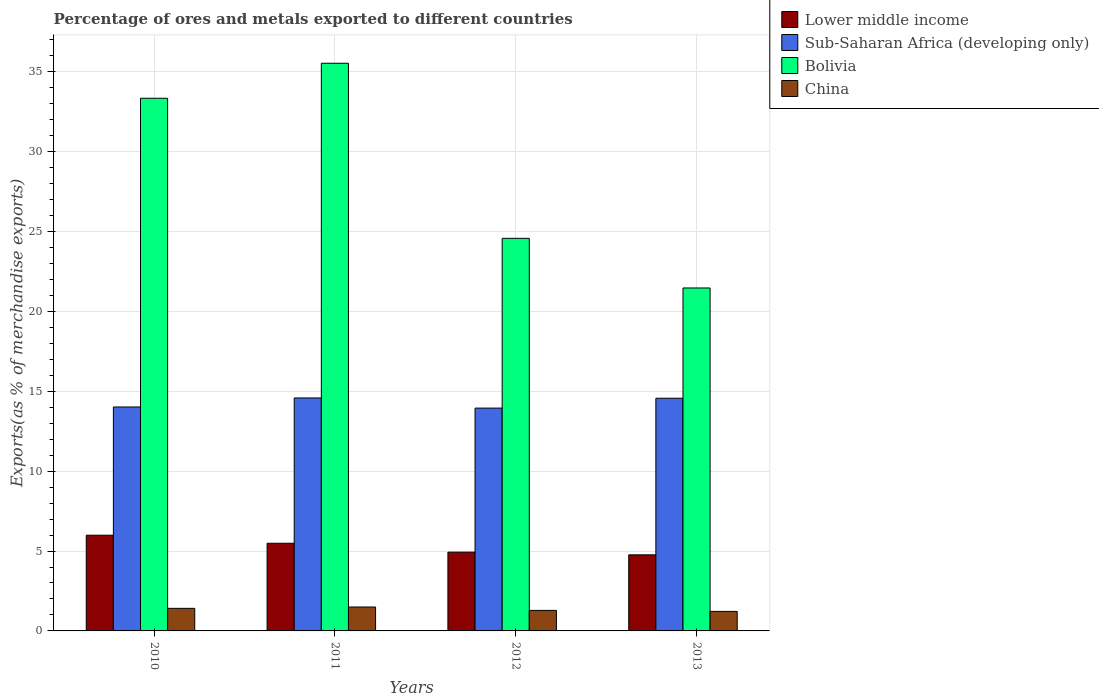How many groups of bars are there?
Keep it short and to the point. 4. Are the number of bars per tick equal to the number of legend labels?
Make the answer very short. Yes. Are the number of bars on each tick of the X-axis equal?
Your response must be concise. Yes. What is the label of the 4th group of bars from the left?
Offer a terse response. 2013. In how many cases, is the number of bars for a given year not equal to the number of legend labels?
Provide a short and direct response. 0. What is the percentage of exports to different countries in Sub-Saharan Africa (developing only) in 2011?
Make the answer very short. 14.58. Across all years, what is the maximum percentage of exports to different countries in Sub-Saharan Africa (developing only)?
Offer a very short reply. 14.58. Across all years, what is the minimum percentage of exports to different countries in Bolivia?
Your answer should be very brief. 21.46. In which year was the percentage of exports to different countries in Sub-Saharan Africa (developing only) maximum?
Your answer should be compact. 2011. In which year was the percentage of exports to different countries in China minimum?
Ensure brevity in your answer.  2013. What is the total percentage of exports to different countries in Sub-Saharan Africa (developing only) in the graph?
Provide a short and direct response. 57.11. What is the difference between the percentage of exports to different countries in Sub-Saharan Africa (developing only) in 2010 and that in 2012?
Keep it short and to the point. 0.07. What is the difference between the percentage of exports to different countries in Bolivia in 2011 and the percentage of exports to different countries in Lower middle income in 2013?
Provide a short and direct response. 30.77. What is the average percentage of exports to different countries in Lower middle income per year?
Your response must be concise. 5.29. In the year 2012, what is the difference between the percentage of exports to different countries in Sub-Saharan Africa (developing only) and percentage of exports to different countries in Lower middle income?
Offer a terse response. 9.02. What is the ratio of the percentage of exports to different countries in China in 2010 to that in 2011?
Provide a succinct answer. 0.94. Is the percentage of exports to different countries in Bolivia in 2012 less than that in 2013?
Make the answer very short. No. What is the difference between the highest and the second highest percentage of exports to different countries in China?
Your answer should be very brief. 0.08. What is the difference between the highest and the lowest percentage of exports to different countries in Sub-Saharan Africa (developing only)?
Your answer should be compact. 0.63. Is it the case that in every year, the sum of the percentage of exports to different countries in Lower middle income and percentage of exports to different countries in Sub-Saharan Africa (developing only) is greater than the sum of percentage of exports to different countries in China and percentage of exports to different countries in Bolivia?
Offer a very short reply. Yes. What does the 4th bar from the left in 2011 represents?
Provide a succinct answer. China. What does the 2nd bar from the right in 2012 represents?
Ensure brevity in your answer.  Bolivia. Is it the case that in every year, the sum of the percentage of exports to different countries in Bolivia and percentage of exports to different countries in Lower middle income is greater than the percentage of exports to different countries in China?
Give a very brief answer. Yes. Are all the bars in the graph horizontal?
Give a very brief answer. No. Are the values on the major ticks of Y-axis written in scientific E-notation?
Give a very brief answer. No. Does the graph contain any zero values?
Offer a very short reply. No. Where does the legend appear in the graph?
Ensure brevity in your answer.  Top right. How many legend labels are there?
Make the answer very short. 4. What is the title of the graph?
Offer a terse response. Percentage of ores and metals exported to different countries. What is the label or title of the X-axis?
Your answer should be very brief. Years. What is the label or title of the Y-axis?
Provide a succinct answer. Exports(as % of merchandise exports). What is the Exports(as % of merchandise exports) in Lower middle income in 2010?
Give a very brief answer. 5.99. What is the Exports(as % of merchandise exports) of Sub-Saharan Africa (developing only) in 2010?
Offer a terse response. 14.02. What is the Exports(as % of merchandise exports) of Bolivia in 2010?
Offer a terse response. 33.34. What is the Exports(as % of merchandise exports) of China in 2010?
Provide a succinct answer. 1.41. What is the Exports(as % of merchandise exports) of Lower middle income in 2011?
Keep it short and to the point. 5.49. What is the Exports(as % of merchandise exports) in Sub-Saharan Africa (developing only) in 2011?
Your response must be concise. 14.58. What is the Exports(as % of merchandise exports) in Bolivia in 2011?
Offer a very short reply. 35.53. What is the Exports(as % of merchandise exports) of China in 2011?
Provide a succinct answer. 1.5. What is the Exports(as % of merchandise exports) in Lower middle income in 2012?
Provide a short and direct response. 4.93. What is the Exports(as % of merchandise exports) in Sub-Saharan Africa (developing only) in 2012?
Your answer should be compact. 13.95. What is the Exports(as % of merchandise exports) in Bolivia in 2012?
Provide a succinct answer. 24.57. What is the Exports(as % of merchandise exports) in China in 2012?
Make the answer very short. 1.28. What is the Exports(as % of merchandise exports) in Lower middle income in 2013?
Keep it short and to the point. 4.76. What is the Exports(as % of merchandise exports) in Sub-Saharan Africa (developing only) in 2013?
Give a very brief answer. 14.56. What is the Exports(as % of merchandise exports) of Bolivia in 2013?
Provide a succinct answer. 21.46. What is the Exports(as % of merchandise exports) of China in 2013?
Ensure brevity in your answer.  1.22. Across all years, what is the maximum Exports(as % of merchandise exports) in Lower middle income?
Make the answer very short. 5.99. Across all years, what is the maximum Exports(as % of merchandise exports) in Sub-Saharan Africa (developing only)?
Offer a terse response. 14.58. Across all years, what is the maximum Exports(as % of merchandise exports) in Bolivia?
Offer a terse response. 35.53. Across all years, what is the maximum Exports(as % of merchandise exports) in China?
Provide a succinct answer. 1.5. Across all years, what is the minimum Exports(as % of merchandise exports) in Lower middle income?
Offer a terse response. 4.76. Across all years, what is the minimum Exports(as % of merchandise exports) in Sub-Saharan Africa (developing only)?
Keep it short and to the point. 13.95. Across all years, what is the minimum Exports(as % of merchandise exports) of Bolivia?
Make the answer very short. 21.46. Across all years, what is the minimum Exports(as % of merchandise exports) in China?
Provide a succinct answer. 1.22. What is the total Exports(as % of merchandise exports) of Lower middle income in the graph?
Keep it short and to the point. 21.17. What is the total Exports(as % of merchandise exports) in Sub-Saharan Africa (developing only) in the graph?
Provide a succinct answer. 57.11. What is the total Exports(as % of merchandise exports) in Bolivia in the graph?
Make the answer very short. 114.91. What is the total Exports(as % of merchandise exports) in China in the graph?
Ensure brevity in your answer.  5.42. What is the difference between the Exports(as % of merchandise exports) in Lower middle income in 2010 and that in 2011?
Offer a terse response. 0.5. What is the difference between the Exports(as % of merchandise exports) of Sub-Saharan Africa (developing only) in 2010 and that in 2011?
Keep it short and to the point. -0.56. What is the difference between the Exports(as % of merchandise exports) of Bolivia in 2010 and that in 2011?
Offer a very short reply. -2.19. What is the difference between the Exports(as % of merchandise exports) in China in 2010 and that in 2011?
Give a very brief answer. -0.08. What is the difference between the Exports(as % of merchandise exports) of Lower middle income in 2010 and that in 2012?
Make the answer very short. 1.06. What is the difference between the Exports(as % of merchandise exports) of Sub-Saharan Africa (developing only) in 2010 and that in 2012?
Make the answer very short. 0.07. What is the difference between the Exports(as % of merchandise exports) of Bolivia in 2010 and that in 2012?
Provide a short and direct response. 8.77. What is the difference between the Exports(as % of merchandise exports) of China in 2010 and that in 2012?
Keep it short and to the point. 0.13. What is the difference between the Exports(as % of merchandise exports) in Lower middle income in 2010 and that in 2013?
Your answer should be very brief. 1.23. What is the difference between the Exports(as % of merchandise exports) in Sub-Saharan Africa (developing only) in 2010 and that in 2013?
Provide a short and direct response. -0.55. What is the difference between the Exports(as % of merchandise exports) in Bolivia in 2010 and that in 2013?
Ensure brevity in your answer.  11.88. What is the difference between the Exports(as % of merchandise exports) in China in 2010 and that in 2013?
Keep it short and to the point. 0.19. What is the difference between the Exports(as % of merchandise exports) in Lower middle income in 2011 and that in 2012?
Make the answer very short. 0.56. What is the difference between the Exports(as % of merchandise exports) of Sub-Saharan Africa (developing only) in 2011 and that in 2012?
Make the answer very short. 0.63. What is the difference between the Exports(as % of merchandise exports) of Bolivia in 2011 and that in 2012?
Offer a terse response. 10.96. What is the difference between the Exports(as % of merchandise exports) in China in 2011 and that in 2012?
Give a very brief answer. 0.21. What is the difference between the Exports(as % of merchandise exports) in Lower middle income in 2011 and that in 2013?
Your response must be concise. 0.72. What is the difference between the Exports(as % of merchandise exports) of Sub-Saharan Africa (developing only) in 2011 and that in 2013?
Offer a terse response. 0.02. What is the difference between the Exports(as % of merchandise exports) of Bolivia in 2011 and that in 2013?
Offer a very short reply. 14.07. What is the difference between the Exports(as % of merchandise exports) in China in 2011 and that in 2013?
Offer a very short reply. 0.27. What is the difference between the Exports(as % of merchandise exports) of Lower middle income in 2012 and that in 2013?
Give a very brief answer. 0.17. What is the difference between the Exports(as % of merchandise exports) in Sub-Saharan Africa (developing only) in 2012 and that in 2013?
Your response must be concise. -0.62. What is the difference between the Exports(as % of merchandise exports) in Bolivia in 2012 and that in 2013?
Give a very brief answer. 3.11. What is the difference between the Exports(as % of merchandise exports) in China in 2012 and that in 2013?
Give a very brief answer. 0.06. What is the difference between the Exports(as % of merchandise exports) of Lower middle income in 2010 and the Exports(as % of merchandise exports) of Sub-Saharan Africa (developing only) in 2011?
Keep it short and to the point. -8.59. What is the difference between the Exports(as % of merchandise exports) of Lower middle income in 2010 and the Exports(as % of merchandise exports) of Bolivia in 2011?
Your answer should be very brief. -29.54. What is the difference between the Exports(as % of merchandise exports) of Lower middle income in 2010 and the Exports(as % of merchandise exports) of China in 2011?
Your response must be concise. 4.49. What is the difference between the Exports(as % of merchandise exports) in Sub-Saharan Africa (developing only) in 2010 and the Exports(as % of merchandise exports) in Bolivia in 2011?
Provide a short and direct response. -21.51. What is the difference between the Exports(as % of merchandise exports) in Sub-Saharan Africa (developing only) in 2010 and the Exports(as % of merchandise exports) in China in 2011?
Offer a very short reply. 12.52. What is the difference between the Exports(as % of merchandise exports) of Bolivia in 2010 and the Exports(as % of merchandise exports) of China in 2011?
Your response must be concise. 31.84. What is the difference between the Exports(as % of merchandise exports) of Lower middle income in 2010 and the Exports(as % of merchandise exports) of Sub-Saharan Africa (developing only) in 2012?
Your response must be concise. -7.96. What is the difference between the Exports(as % of merchandise exports) in Lower middle income in 2010 and the Exports(as % of merchandise exports) in Bolivia in 2012?
Your response must be concise. -18.58. What is the difference between the Exports(as % of merchandise exports) of Lower middle income in 2010 and the Exports(as % of merchandise exports) of China in 2012?
Offer a terse response. 4.71. What is the difference between the Exports(as % of merchandise exports) in Sub-Saharan Africa (developing only) in 2010 and the Exports(as % of merchandise exports) in Bolivia in 2012?
Give a very brief answer. -10.56. What is the difference between the Exports(as % of merchandise exports) of Sub-Saharan Africa (developing only) in 2010 and the Exports(as % of merchandise exports) of China in 2012?
Offer a terse response. 12.73. What is the difference between the Exports(as % of merchandise exports) in Bolivia in 2010 and the Exports(as % of merchandise exports) in China in 2012?
Provide a short and direct response. 32.06. What is the difference between the Exports(as % of merchandise exports) of Lower middle income in 2010 and the Exports(as % of merchandise exports) of Sub-Saharan Africa (developing only) in 2013?
Offer a very short reply. -8.57. What is the difference between the Exports(as % of merchandise exports) of Lower middle income in 2010 and the Exports(as % of merchandise exports) of Bolivia in 2013?
Give a very brief answer. -15.47. What is the difference between the Exports(as % of merchandise exports) of Lower middle income in 2010 and the Exports(as % of merchandise exports) of China in 2013?
Your answer should be very brief. 4.77. What is the difference between the Exports(as % of merchandise exports) in Sub-Saharan Africa (developing only) in 2010 and the Exports(as % of merchandise exports) in Bolivia in 2013?
Make the answer very short. -7.45. What is the difference between the Exports(as % of merchandise exports) in Sub-Saharan Africa (developing only) in 2010 and the Exports(as % of merchandise exports) in China in 2013?
Offer a very short reply. 12.79. What is the difference between the Exports(as % of merchandise exports) of Bolivia in 2010 and the Exports(as % of merchandise exports) of China in 2013?
Give a very brief answer. 32.12. What is the difference between the Exports(as % of merchandise exports) of Lower middle income in 2011 and the Exports(as % of merchandise exports) of Sub-Saharan Africa (developing only) in 2012?
Give a very brief answer. -8.46. What is the difference between the Exports(as % of merchandise exports) in Lower middle income in 2011 and the Exports(as % of merchandise exports) in Bolivia in 2012?
Give a very brief answer. -19.09. What is the difference between the Exports(as % of merchandise exports) of Lower middle income in 2011 and the Exports(as % of merchandise exports) of China in 2012?
Give a very brief answer. 4.2. What is the difference between the Exports(as % of merchandise exports) in Sub-Saharan Africa (developing only) in 2011 and the Exports(as % of merchandise exports) in Bolivia in 2012?
Provide a succinct answer. -9.99. What is the difference between the Exports(as % of merchandise exports) in Sub-Saharan Africa (developing only) in 2011 and the Exports(as % of merchandise exports) in China in 2012?
Your response must be concise. 13.3. What is the difference between the Exports(as % of merchandise exports) of Bolivia in 2011 and the Exports(as % of merchandise exports) of China in 2012?
Offer a very short reply. 34.25. What is the difference between the Exports(as % of merchandise exports) of Lower middle income in 2011 and the Exports(as % of merchandise exports) of Sub-Saharan Africa (developing only) in 2013?
Ensure brevity in your answer.  -9.08. What is the difference between the Exports(as % of merchandise exports) in Lower middle income in 2011 and the Exports(as % of merchandise exports) in Bolivia in 2013?
Your answer should be very brief. -15.98. What is the difference between the Exports(as % of merchandise exports) in Lower middle income in 2011 and the Exports(as % of merchandise exports) in China in 2013?
Your answer should be very brief. 4.26. What is the difference between the Exports(as % of merchandise exports) of Sub-Saharan Africa (developing only) in 2011 and the Exports(as % of merchandise exports) of Bolivia in 2013?
Give a very brief answer. -6.88. What is the difference between the Exports(as % of merchandise exports) of Sub-Saharan Africa (developing only) in 2011 and the Exports(as % of merchandise exports) of China in 2013?
Keep it short and to the point. 13.36. What is the difference between the Exports(as % of merchandise exports) in Bolivia in 2011 and the Exports(as % of merchandise exports) in China in 2013?
Give a very brief answer. 34.31. What is the difference between the Exports(as % of merchandise exports) in Lower middle income in 2012 and the Exports(as % of merchandise exports) in Sub-Saharan Africa (developing only) in 2013?
Give a very brief answer. -9.63. What is the difference between the Exports(as % of merchandise exports) of Lower middle income in 2012 and the Exports(as % of merchandise exports) of Bolivia in 2013?
Offer a very short reply. -16.53. What is the difference between the Exports(as % of merchandise exports) of Lower middle income in 2012 and the Exports(as % of merchandise exports) of China in 2013?
Give a very brief answer. 3.71. What is the difference between the Exports(as % of merchandise exports) in Sub-Saharan Africa (developing only) in 2012 and the Exports(as % of merchandise exports) in Bolivia in 2013?
Offer a terse response. -7.52. What is the difference between the Exports(as % of merchandise exports) in Sub-Saharan Africa (developing only) in 2012 and the Exports(as % of merchandise exports) in China in 2013?
Offer a terse response. 12.72. What is the difference between the Exports(as % of merchandise exports) in Bolivia in 2012 and the Exports(as % of merchandise exports) in China in 2013?
Your response must be concise. 23.35. What is the average Exports(as % of merchandise exports) of Lower middle income per year?
Your response must be concise. 5.29. What is the average Exports(as % of merchandise exports) of Sub-Saharan Africa (developing only) per year?
Your answer should be compact. 14.28. What is the average Exports(as % of merchandise exports) in Bolivia per year?
Provide a short and direct response. 28.73. What is the average Exports(as % of merchandise exports) of China per year?
Give a very brief answer. 1.35. In the year 2010, what is the difference between the Exports(as % of merchandise exports) of Lower middle income and Exports(as % of merchandise exports) of Sub-Saharan Africa (developing only)?
Ensure brevity in your answer.  -8.03. In the year 2010, what is the difference between the Exports(as % of merchandise exports) in Lower middle income and Exports(as % of merchandise exports) in Bolivia?
Offer a terse response. -27.35. In the year 2010, what is the difference between the Exports(as % of merchandise exports) in Lower middle income and Exports(as % of merchandise exports) in China?
Your answer should be very brief. 4.58. In the year 2010, what is the difference between the Exports(as % of merchandise exports) in Sub-Saharan Africa (developing only) and Exports(as % of merchandise exports) in Bolivia?
Ensure brevity in your answer.  -19.32. In the year 2010, what is the difference between the Exports(as % of merchandise exports) of Sub-Saharan Africa (developing only) and Exports(as % of merchandise exports) of China?
Your response must be concise. 12.6. In the year 2010, what is the difference between the Exports(as % of merchandise exports) in Bolivia and Exports(as % of merchandise exports) in China?
Your answer should be very brief. 31.93. In the year 2011, what is the difference between the Exports(as % of merchandise exports) of Lower middle income and Exports(as % of merchandise exports) of Sub-Saharan Africa (developing only)?
Ensure brevity in your answer.  -9.09. In the year 2011, what is the difference between the Exports(as % of merchandise exports) of Lower middle income and Exports(as % of merchandise exports) of Bolivia?
Your response must be concise. -30.04. In the year 2011, what is the difference between the Exports(as % of merchandise exports) of Lower middle income and Exports(as % of merchandise exports) of China?
Make the answer very short. 3.99. In the year 2011, what is the difference between the Exports(as % of merchandise exports) in Sub-Saharan Africa (developing only) and Exports(as % of merchandise exports) in Bolivia?
Ensure brevity in your answer.  -20.95. In the year 2011, what is the difference between the Exports(as % of merchandise exports) in Sub-Saharan Africa (developing only) and Exports(as % of merchandise exports) in China?
Give a very brief answer. 13.08. In the year 2011, what is the difference between the Exports(as % of merchandise exports) of Bolivia and Exports(as % of merchandise exports) of China?
Ensure brevity in your answer.  34.03. In the year 2012, what is the difference between the Exports(as % of merchandise exports) in Lower middle income and Exports(as % of merchandise exports) in Sub-Saharan Africa (developing only)?
Your answer should be compact. -9.02. In the year 2012, what is the difference between the Exports(as % of merchandise exports) of Lower middle income and Exports(as % of merchandise exports) of Bolivia?
Keep it short and to the point. -19.64. In the year 2012, what is the difference between the Exports(as % of merchandise exports) of Lower middle income and Exports(as % of merchandise exports) of China?
Offer a very short reply. 3.65. In the year 2012, what is the difference between the Exports(as % of merchandise exports) of Sub-Saharan Africa (developing only) and Exports(as % of merchandise exports) of Bolivia?
Your response must be concise. -10.63. In the year 2012, what is the difference between the Exports(as % of merchandise exports) in Sub-Saharan Africa (developing only) and Exports(as % of merchandise exports) in China?
Make the answer very short. 12.66. In the year 2012, what is the difference between the Exports(as % of merchandise exports) of Bolivia and Exports(as % of merchandise exports) of China?
Give a very brief answer. 23.29. In the year 2013, what is the difference between the Exports(as % of merchandise exports) in Lower middle income and Exports(as % of merchandise exports) in Sub-Saharan Africa (developing only)?
Your response must be concise. -9.8. In the year 2013, what is the difference between the Exports(as % of merchandise exports) of Lower middle income and Exports(as % of merchandise exports) of Bolivia?
Offer a terse response. -16.7. In the year 2013, what is the difference between the Exports(as % of merchandise exports) of Lower middle income and Exports(as % of merchandise exports) of China?
Ensure brevity in your answer.  3.54. In the year 2013, what is the difference between the Exports(as % of merchandise exports) in Sub-Saharan Africa (developing only) and Exports(as % of merchandise exports) in Bolivia?
Provide a succinct answer. -6.9. In the year 2013, what is the difference between the Exports(as % of merchandise exports) of Sub-Saharan Africa (developing only) and Exports(as % of merchandise exports) of China?
Provide a succinct answer. 13.34. In the year 2013, what is the difference between the Exports(as % of merchandise exports) of Bolivia and Exports(as % of merchandise exports) of China?
Make the answer very short. 20.24. What is the ratio of the Exports(as % of merchandise exports) in Lower middle income in 2010 to that in 2011?
Provide a succinct answer. 1.09. What is the ratio of the Exports(as % of merchandise exports) in Sub-Saharan Africa (developing only) in 2010 to that in 2011?
Keep it short and to the point. 0.96. What is the ratio of the Exports(as % of merchandise exports) in Bolivia in 2010 to that in 2011?
Ensure brevity in your answer.  0.94. What is the ratio of the Exports(as % of merchandise exports) of China in 2010 to that in 2011?
Keep it short and to the point. 0.94. What is the ratio of the Exports(as % of merchandise exports) of Lower middle income in 2010 to that in 2012?
Provide a short and direct response. 1.22. What is the ratio of the Exports(as % of merchandise exports) of Bolivia in 2010 to that in 2012?
Keep it short and to the point. 1.36. What is the ratio of the Exports(as % of merchandise exports) in China in 2010 to that in 2012?
Provide a succinct answer. 1.1. What is the ratio of the Exports(as % of merchandise exports) of Lower middle income in 2010 to that in 2013?
Provide a short and direct response. 1.26. What is the ratio of the Exports(as % of merchandise exports) in Sub-Saharan Africa (developing only) in 2010 to that in 2013?
Your answer should be very brief. 0.96. What is the ratio of the Exports(as % of merchandise exports) of Bolivia in 2010 to that in 2013?
Provide a succinct answer. 1.55. What is the ratio of the Exports(as % of merchandise exports) of China in 2010 to that in 2013?
Keep it short and to the point. 1.15. What is the ratio of the Exports(as % of merchandise exports) of Lower middle income in 2011 to that in 2012?
Ensure brevity in your answer.  1.11. What is the ratio of the Exports(as % of merchandise exports) of Sub-Saharan Africa (developing only) in 2011 to that in 2012?
Make the answer very short. 1.05. What is the ratio of the Exports(as % of merchandise exports) of Bolivia in 2011 to that in 2012?
Keep it short and to the point. 1.45. What is the ratio of the Exports(as % of merchandise exports) in China in 2011 to that in 2012?
Offer a very short reply. 1.17. What is the ratio of the Exports(as % of merchandise exports) in Lower middle income in 2011 to that in 2013?
Your response must be concise. 1.15. What is the ratio of the Exports(as % of merchandise exports) of Sub-Saharan Africa (developing only) in 2011 to that in 2013?
Offer a terse response. 1. What is the ratio of the Exports(as % of merchandise exports) in Bolivia in 2011 to that in 2013?
Make the answer very short. 1.66. What is the ratio of the Exports(as % of merchandise exports) of China in 2011 to that in 2013?
Offer a terse response. 1.22. What is the ratio of the Exports(as % of merchandise exports) in Lower middle income in 2012 to that in 2013?
Ensure brevity in your answer.  1.04. What is the ratio of the Exports(as % of merchandise exports) in Sub-Saharan Africa (developing only) in 2012 to that in 2013?
Your answer should be compact. 0.96. What is the ratio of the Exports(as % of merchandise exports) in Bolivia in 2012 to that in 2013?
Keep it short and to the point. 1.14. What is the ratio of the Exports(as % of merchandise exports) in China in 2012 to that in 2013?
Offer a very short reply. 1.05. What is the difference between the highest and the second highest Exports(as % of merchandise exports) in Lower middle income?
Keep it short and to the point. 0.5. What is the difference between the highest and the second highest Exports(as % of merchandise exports) of Sub-Saharan Africa (developing only)?
Provide a short and direct response. 0.02. What is the difference between the highest and the second highest Exports(as % of merchandise exports) in Bolivia?
Ensure brevity in your answer.  2.19. What is the difference between the highest and the second highest Exports(as % of merchandise exports) in China?
Your answer should be compact. 0.08. What is the difference between the highest and the lowest Exports(as % of merchandise exports) of Lower middle income?
Your answer should be compact. 1.23. What is the difference between the highest and the lowest Exports(as % of merchandise exports) of Sub-Saharan Africa (developing only)?
Provide a succinct answer. 0.63. What is the difference between the highest and the lowest Exports(as % of merchandise exports) in Bolivia?
Provide a short and direct response. 14.07. What is the difference between the highest and the lowest Exports(as % of merchandise exports) of China?
Offer a terse response. 0.27. 